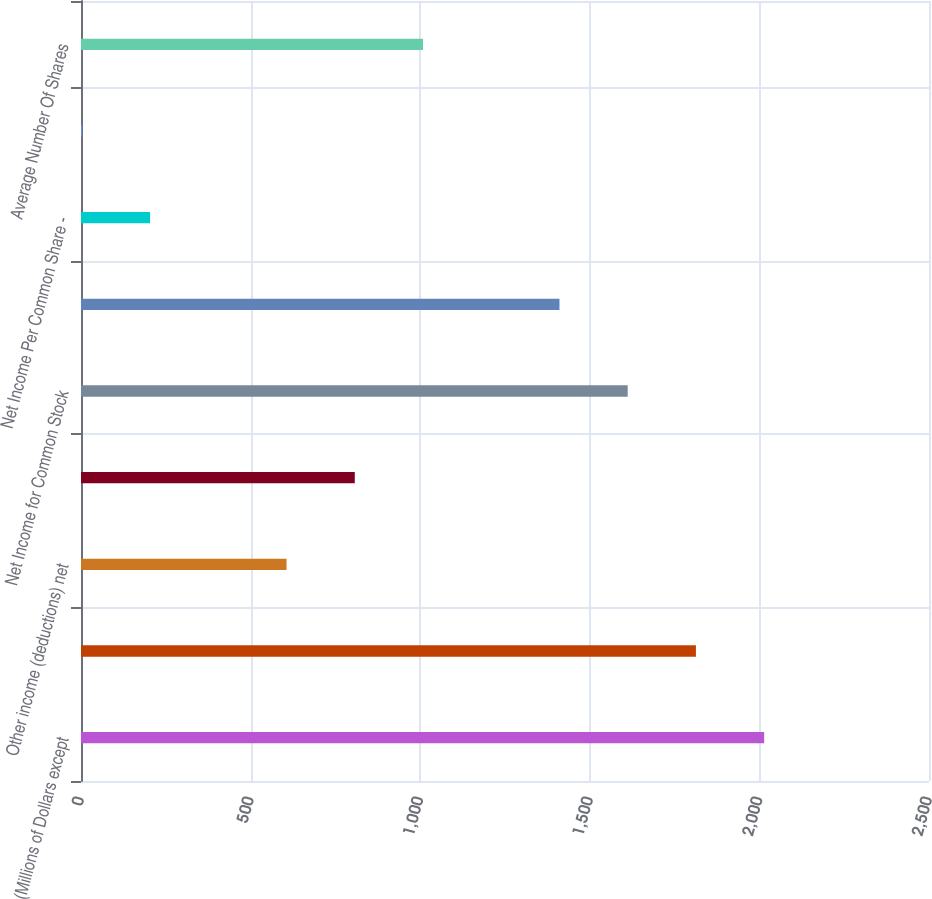Convert chart. <chart><loc_0><loc_0><loc_500><loc_500><bar_chart><fcel>(Millions of Dollars except<fcel>Equity in earnings of<fcel>Other income (deductions) net<fcel>Interest expense<fcel>Net Income for Common Stock<fcel>Comprehensive Income for<fcel>Net Income Per Common Share -<fcel>Dividends Declared Per Share<fcel>Average Number Of Shares<nl><fcel>2014.02<fcel>1812.87<fcel>605.97<fcel>807.12<fcel>1611.72<fcel>1410.57<fcel>203.67<fcel>2.52<fcel>1008.27<nl></chart> 